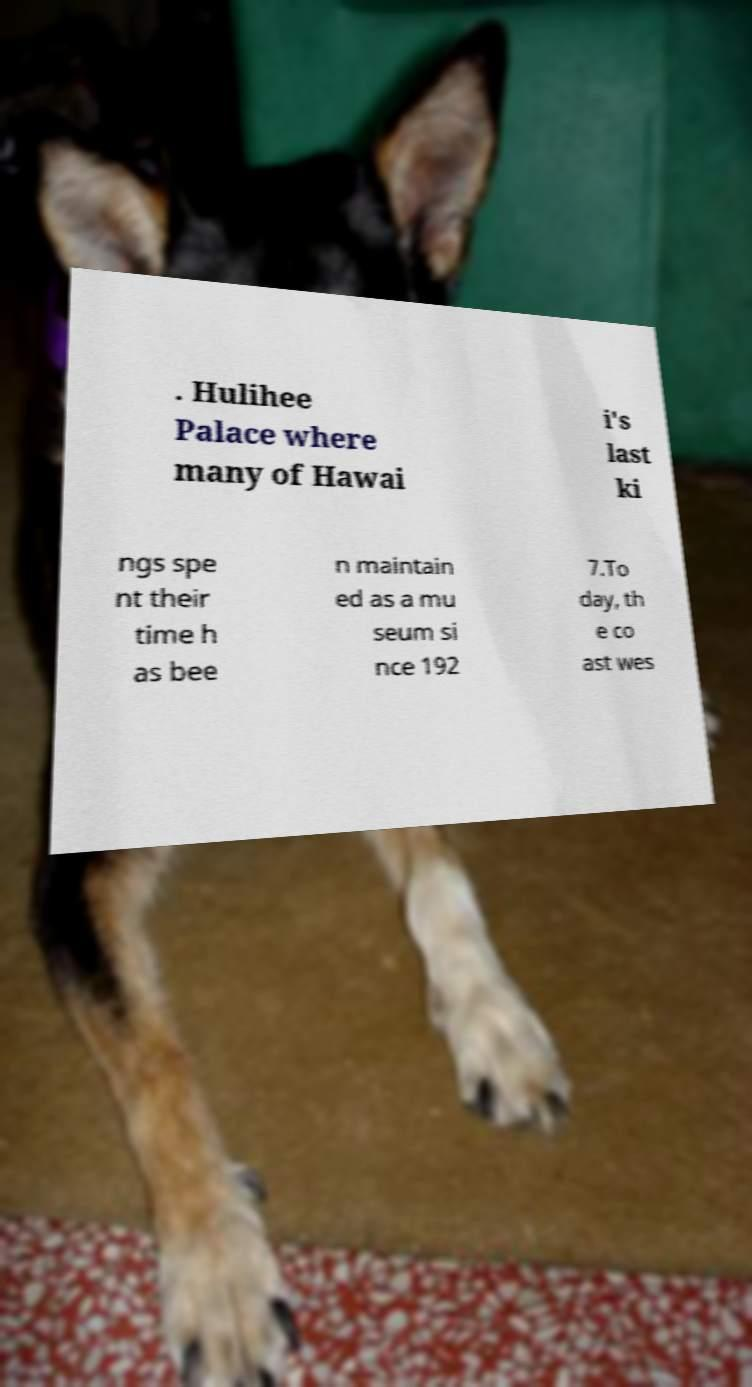Can you accurately transcribe the text from the provided image for me? . Hulihee Palace where many of Hawai i's last ki ngs spe nt their time h as bee n maintain ed as a mu seum si nce 192 7.To day, th e co ast wes 